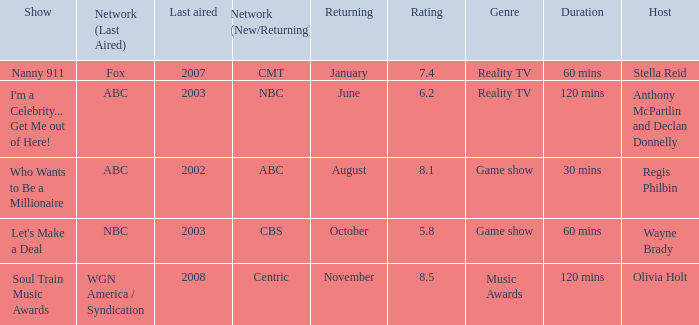When did a show last aired in 2002 return? August. Would you be able to parse every entry in this table? {'header': ['Show', 'Network (Last Aired)', 'Last aired', 'Network (New/Returning)', 'Returning', 'Rating', 'Genre', 'Duration', 'Host'], 'rows': [['Nanny 911', 'Fox', '2007', 'CMT', 'January', '7.4', 'Reality TV', '60 mins', 'Stella Reid'], ["I'm a Celebrity... Get Me out of Here!", 'ABC', '2003', 'NBC', 'June', '6.2', 'Reality TV', '120 mins', 'Anthony McPartlin and Declan Donnelly'], ['Who Wants to Be a Millionaire', 'ABC', '2002', 'ABC', 'August', '8.1', 'Game show', '30 mins', 'Regis Philbin'], ["Let's Make a Deal", 'NBC', '2003', 'CBS', 'October', '5.8', 'Game show', '60 mins', 'Wayne Brady'], ['Soul Train Music Awards', 'WGN America / Syndication', '2008', 'Centric', 'November', '8.5', 'Music Awards', '120 mins', 'Olivia Holt']]} 